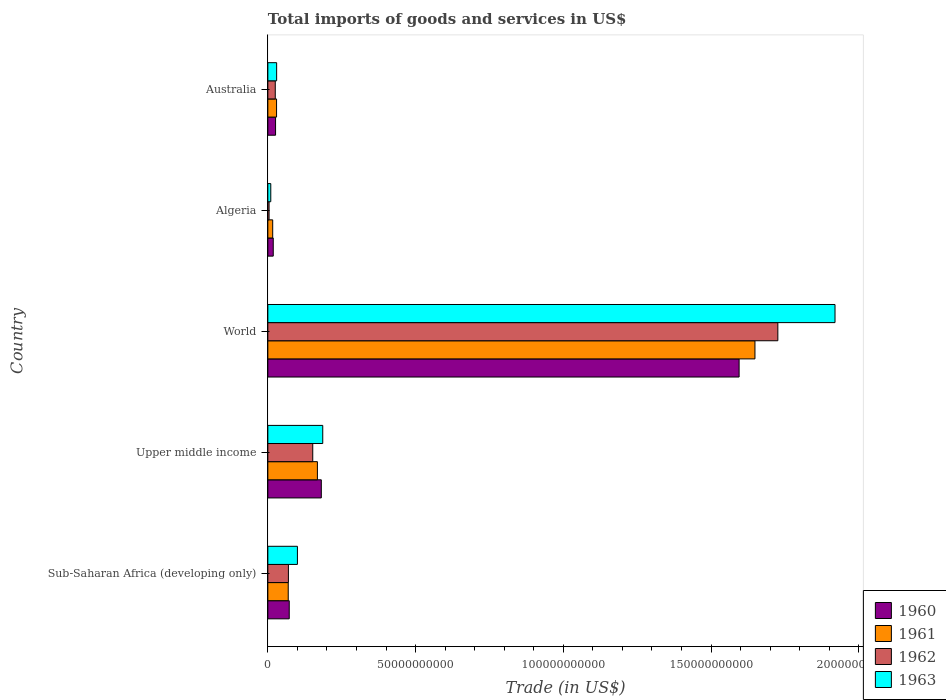How many bars are there on the 2nd tick from the top?
Your answer should be very brief. 4. What is the label of the 5th group of bars from the top?
Provide a short and direct response. Sub-Saharan Africa (developing only). In how many cases, is the number of bars for a given country not equal to the number of legend labels?
Ensure brevity in your answer.  0. What is the total imports of goods and services in 1962 in World?
Your answer should be compact. 1.73e+11. Across all countries, what is the maximum total imports of goods and services in 1963?
Give a very brief answer. 1.92e+11. Across all countries, what is the minimum total imports of goods and services in 1962?
Ensure brevity in your answer.  4.17e+08. In which country was the total imports of goods and services in 1962 maximum?
Offer a terse response. World. In which country was the total imports of goods and services in 1960 minimum?
Provide a succinct answer. Algeria. What is the total total imports of goods and services in 1961 in the graph?
Provide a succinct answer. 1.93e+11. What is the difference between the total imports of goods and services in 1962 in Upper middle income and that in World?
Your response must be concise. -1.57e+11. What is the difference between the total imports of goods and services in 1963 in Australia and the total imports of goods and services in 1962 in Upper middle income?
Your answer should be compact. -1.22e+1. What is the average total imports of goods and services in 1960 per country?
Provide a short and direct response. 3.79e+1. What is the difference between the total imports of goods and services in 1963 and total imports of goods and services in 1960 in Algeria?
Give a very brief answer. -8.33e+08. In how many countries, is the total imports of goods and services in 1963 greater than 100000000000 US$?
Make the answer very short. 1. What is the ratio of the total imports of goods and services in 1960 in Algeria to that in Sub-Saharan Africa (developing only)?
Offer a very short reply. 0.25. Is the difference between the total imports of goods and services in 1963 in Sub-Saharan Africa (developing only) and World greater than the difference between the total imports of goods and services in 1960 in Sub-Saharan Africa (developing only) and World?
Keep it short and to the point. No. What is the difference between the highest and the second highest total imports of goods and services in 1963?
Your response must be concise. 1.73e+11. What is the difference between the highest and the lowest total imports of goods and services in 1961?
Offer a terse response. 1.63e+11. Is it the case that in every country, the sum of the total imports of goods and services in 1961 and total imports of goods and services in 1963 is greater than the sum of total imports of goods and services in 1960 and total imports of goods and services in 1962?
Keep it short and to the point. No. What does the 4th bar from the top in World represents?
Ensure brevity in your answer.  1960. What does the 4th bar from the bottom in World represents?
Give a very brief answer. 1963. Is it the case that in every country, the sum of the total imports of goods and services in 1962 and total imports of goods and services in 1961 is greater than the total imports of goods and services in 1963?
Your answer should be compact. Yes. How many countries are there in the graph?
Your answer should be very brief. 5. Does the graph contain any zero values?
Ensure brevity in your answer.  No. Does the graph contain grids?
Make the answer very short. No. Where does the legend appear in the graph?
Provide a succinct answer. Bottom right. What is the title of the graph?
Make the answer very short. Total imports of goods and services in US$. Does "2000" appear as one of the legend labels in the graph?
Give a very brief answer. No. What is the label or title of the X-axis?
Your response must be concise. Trade (in US$). What is the Trade (in US$) of 1960 in Sub-Saharan Africa (developing only)?
Your answer should be very brief. 7.24e+09. What is the Trade (in US$) in 1961 in Sub-Saharan Africa (developing only)?
Ensure brevity in your answer.  6.90e+09. What is the Trade (in US$) in 1962 in Sub-Saharan Africa (developing only)?
Make the answer very short. 6.96e+09. What is the Trade (in US$) in 1963 in Sub-Saharan Africa (developing only)?
Your answer should be compact. 1.00e+1. What is the Trade (in US$) of 1960 in Upper middle income?
Your response must be concise. 1.81e+1. What is the Trade (in US$) of 1961 in Upper middle income?
Make the answer very short. 1.68e+1. What is the Trade (in US$) in 1962 in Upper middle income?
Offer a terse response. 1.52e+1. What is the Trade (in US$) in 1963 in Upper middle income?
Provide a short and direct response. 1.86e+1. What is the Trade (in US$) of 1960 in World?
Give a very brief answer. 1.59e+11. What is the Trade (in US$) in 1961 in World?
Keep it short and to the point. 1.65e+11. What is the Trade (in US$) of 1962 in World?
Provide a short and direct response. 1.73e+11. What is the Trade (in US$) of 1963 in World?
Your answer should be compact. 1.92e+11. What is the Trade (in US$) in 1960 in Algeria?
Provide a succinct answer. 1.83e+09. What is the Trade (in US$) of 1961 in Algeria?
Your answer should be compact. 1.64e+09. What is the Trade (in US$) in 1962 in Algeria?
Ensure brevity in your answer.  4.17e+08. What is the Trade (in US$) in 1963 in Algeria?
Provide a succinct answer. 9.95e+08. What is the Trade (in US$) of 1960 in Australia?
Give a very brief answer. 2.61e+09. What is the Trade (in US$) of 1961 in Australia?
Provide a short and direct response. 2.95e+09. What is the Trade (in US$) in 1962 in Australia?
Ensure brevity in your answer.  2.51e+09. What is the Trade (in US$) of 1963 in Australia?
Your answer should be very brief. 2.97e+09. Across all countries, what is the maximum Trade (in US$) of 1960?
Ensure brevity in your answer.  1.59e+11. Across all countries, what is the maximum Trade (in US$) of 1961?
Your answer should be compact. 1.65e+11. Across all countries, what is the maximum Trade (in US$) in 1962?
Provide a short and direct response. 1.73e+11. Across all countries, what is the maximum Trade (in US$) in 1963?
Offer a very short reply. 1.92e+11. Across all countries, what is the minimum Trade (in US$) in 1960?
Your response must be concise. 1.83e+09. Across all countries, what is the minimum Trade (in US$) in 1961?
Your answer should be compact. 1.64e+09. Across all countries, what is the minimum Trade (in US$) in 1962?
Keep it short and to the point. 4.17e+08. Across all countries, what is the minimum Trade (in US$) of 1963?
Your answer should be compact. 9.95e+08. What is the total Trade (in US$) in 1960 in the graph?
Offer a very short reply. 1.89e+11. What is the total Trade (in US$) in 1961 in the graph?
Offer a terse response. 1.93e+11. What is the total Trade (in US$) in 1962 in the graph?
Offer a very short reply. 1.98e+11. What is the total Trade (in US$) of 1963 in the graph?
Give a very brief answer. 2.25e+11. What is the difference between the Trade (in US$) in 1960 in Sub-Saharan Africa (developing only) and that in Upper middle income?
Ensure brevity in your answer.  -1.09e+1. What is the difference between the Trade (in US$) in 1961 in Sub-Saharan Africa (developing only) and that in Upper middle income?
Provide a short and direct response. -9.87e+09. What is the difference between the Trade (in US$) of 1962 in Sub-Saharan Africa (developing only) and that in Upper middle income?
Ensure brevity in your answer.  -8.24e+09. What is the difference between the Trade (in US$) in 1963 in Sub-Saharan Africa (developing only) and that in Upper middle income?
Provide a succinct answer. -8.57e+09. What is the difference between the Trade (in US$) in 1960 in Sub-Saharan Africa (developing only) and that in World?
Your answer should be compact. -1.52e+11. What is the difference between the Trade (in US$) in 1961 in Sub-Saharan Africa (developing only) and that in World?
Keep it short and to the point. -1.58e+11. What is the difference between the Trade (in US$) in 1962 in Sub-Saharan Africa (developing only) and that in World?
Ensure brevity in your answer.  -1.66e+11. What is the difference between the Trade (in US$) in 1963 in Sub-Saharan Africa (developing only) and that in World?
Provide a short and direct response. -1.82e+11. What is the difference between the Trade (in US$) of 1960 in Sub-Saharan Africa (developing only) and that in Algeria?
Provide a short and direct response. 5.41e+09. What is the difference between the Trade (in US$) of 1961 in Sub-Saharan Africa (developing only) and that in Algeria?
Ensure brevity in your answer.  5.26e+09. What is the difference between the Trade (in US$) of 1962 in Sub-Saharan Africa (developing only) and that in Algeria?
Your answer should be very brief. 6.54e+09. What is the difference between the Trade (in US$) of 1963 in Sub-Saharan Africa (developing only) and that in Algeria?
Provide a short and direct response. 9.02e+09. What is the difference between the Trade (in US$) in 1960 in Sub-Saharan Africa (developing only) and that in Australia?
Provide a short and direct response. 4.63e+09. What is the difference between the Trade (in US$) of 1961 in Sub-Saharan Africa (developing only) and that in Australia?
Your answer should be compact. 3.95e+09. What is the difference between the Trade (in US$) in 1962 in Sub-Saharan Africa (developing only) and that in Australia?
Your response must be concise. 4.45e+09. What is the difference between the Trade (in US$) in 1963 in Sub-Saharan Africa (developing only) and that in Australia?
Make the answer very short. 7.04e+09. What is the difference between the Trade (in US$) in 1960 in Upper middle income and that in World?
Offer a terse response. -1.41e+11. What is the difference between the Trade (in US$) in 1961 in Upper middle income and that in World?
Give a very brief answer. -1.48e+11. What is the difference between the Trade (in US$) in 1962 in Upper middle income and that in World?
Offer a terse response. -1.57e+11. What is the difference between the Trade (in US$) of 1963 in Upper middle income and that in World?
Your answer should be compact. -1.73e+11. What is the difference between the Trade (in US$) of 1960 in Upper middle income and that in Algeria?
Give a very brief answer. 1.63e+1. What is the difference between the Trade (in US$) in 1961 in Upper middle income and that in Algeria?
Offer a terse response. 1.51e+1. What is the difference between the Trade (in US$) of 1962 in Upper middle income and that in Algeria?
Ensure brevity in your answer.  1.48e+1. What is the difference between the Trade (in US$) in 1963 in Upper middle income and that in Algeria?
Keep it short and to the point. 1.76e+1. What is the difference between the Trade (in US$) of 1960 in Upper middle income and that in Australia?
Your answer should be compact. 1.55e+1. What is the difference between the Trade (in US$) in 1961 in Upper middle income and that in Australia?
Your response must be concise. 1.38e+1. What is the difference between the Trade (in US$) of 1962 in Upper middle income and that in Australia?
Provide a succinct answer. 1.27e+1. What is the difference between the Trade (in US$) of 1963 in Upper middle income and that in Australia?
Give a very brief answer. 1.56e+1. What is the difference between the Trade (in US$) of 1960 in World and that in Algeria?
Give a very brief answer. 1.58e+11. What is the difference between the Trade (in US$) of 1961 in World and that in Algeria?
Your response must be concise. 1.63e+11. What is the difference between the Trade (in US$) in 1962 in World and that in Algeria?
Provide a short and direct response. 1.72e+11. What is the difference between the Trade (in US$) in 1963 in World and that in Algeria?
Offer a very short reply. 1.91e+11. What is the difference between the Trade (in US$) in 1960 in World and that in Australia?
Give a very brief answer. 1.57e+11. What is the difference between the Trade (in US$) of 1961 in World and that in Australia?
Give a very brief answer. 1.62e+11. What is the difference between the Trade (in US$) in 1962 in World and that in Australia?
Your answer should be compact. 1.70e+11. What is the difference between the Trade (in US$) in 1963 in World and that in Australia?
Provide a succinct answer. 1.89e+11. What is the difference between the Trade (in US$) in 1960 in Algeria and that in Australia?
Provide a short and direct response. -7.83e+08. What is the difference between the Trade (in US$) of 1961 in Algeria and that in Australia?
Make the answer very short. -1.31e+09. What is the difference between the Trade (in US$) in 1962 in Algeria and that in Australia?
Provide a short and direct response. -2.10e+09. What is the difference between the Trade (in US$) of 1963 in Algeria and that in Australia?
Give a very brief answer. -1.98e+09. What is the difference between the Trade (in US$) in 1960 in Sub-Saharan Africa (developing only) and the Trade (in US$) in 1961 in Upper middle income?
Your answer should be compact. -9.54e+09. What is the difference between the Trade (in US$) in 1960 in Sub-Saharan Africa (developing only) and the Trade (in US$) in 1962 in Upper middle income?
Give a very brief answer. -7.96e+09. What is the difference between the Trade (in US$) in 1960 in Sub-Saharan Africa (developing only) and the Trade (in US$) in 1963 in Upper middle income?
Offer a terse response. -1.13e+1. What is the difference between the Trade (in US$) in 1961 in Sub-Saharan Africa (developing only) and the Trade (in US$) in 1962 in Upper middle income?
Your answer should be very brief. -8.29e+09. What is the difference between the Trade (in US$) of 1961 in Sub-Saharan Africa (developing only) and the Trade (in US$) of 1963 in Upper middle income?
Offer a very short reply. -1.17e+1. What is the difference between the Trade (in US$) in 1962 in Sub-Saharan Africa (developing only) and the Trade (in US$) in 1963 in Upper middle income?
Offer a very short reply. -1.16e+1. What is the difference between the Trade (in US$) in 1960 in Sub-Saharan Africa (developing only) and the Trade (in US$) in 1961 in World?
Provide a short and direct response. -1.58e+11. What is the difference between the Trade (in US$) in 1960 in Sub-Saharan Africa (developing only) and the Trade (in US$) in 1962 in World?
Provide a succinct answer. -1.65e+11. What is the difference between the Trade (in US$) of 1960 in Sub-Saharan Africa (developing only) and the Trade (in US$) of 1963 in World?
Give a very brief answer. -1.85e+11. What is the difference between the Trade (in US$) in 1961 in Sub-Saharan Africa (developing only) and the Trade (in US$) in 1962 in World?
Offer a terse response. -1.66e+11. What is the difference between the Trade (in US$) of 1961 in Sub-Saharan Africa (developing only) and the Trade (in US$) of 1963 in World?
Your answer should be compact. -1.85e+11. What is the difference between the Trade (in US$) in 1962 in Sub-Saharan Africa (developing only) and the Trade (in US$) in 1963 in World?
Offer a terse response. -1.85e+11. What is the difference between the Trade (in US$) of 1960 in Sub-Saharan Africa (developing only) and the Trade (in US$) of 1961 in Algeria?
Make the answer very short. 5.59e+09. What is the difference between the Trade (in US$) in 1960 in Sub-Saharan Africa (developing only) and the Trade (in US$) in 1962 in Algeria?
Ensure brevity in your answer.  6.82e+09. What is the difference between the Trade (in US$) of 1960 in Sub-Saharan Africa (developing only) and the Trade (in US$) of 1963 in Algeria?
Your answer should be very brief. 6.24e+09. What is the difference between the Trade (in US$) in 1961 in Sub-Saharan Africa (developing only) and the Trade (in US$) in 1962 in Algeria?
Offer a terse response. 6.49e+09. What is the difference between the Trade (in US$) of 1961 in Sub-Saharan Africa (developing only) and the Trade (in US$) of 1963 in Algeria?
Make the answer very short. 5.91e+09. What is the difference between the Trade (in US$) in 1962 in Sub-Saharan Africa (developing only) and the Trade (in US$) in 1963 in Algeria?
Your response must be concise. 5.97e+09. What is the difference between the Trade (in US$) of 1960 in Sub-Saharan Africa (developing only) and the Trade (in US$) of 1961 in Australia?
Give a very brief answer. 4.29e+09. What is the difference between the Trade (in US$) in 1960 in Sub-Saharan Africa (developing only) and the Trade (in US$) in 1962 in Australia?
Keep it short and to the point. 4.73e+09. What is the difference between the Trade (in US$) of 1960 in Sub-Saharan Africa (developing only) and the Trade (in US$) of 1963 in Australia?
Make the answer very short. 4.26e+09. What is the difference between the Trade (in US$) in 1961 in Sub-Saharan Africa (developing only) and the Trade (in US$) in 1962 in Australia?
Offer a very short reply. 4.39e+09. What is the difference between the Trade (in US$) in 1961 in Sub-Saharan Africa (developing only) and the Trade (in US$) in 1963 in Australia?
Keep it short and to the point. 3.93e+09. What is the difference between the Trade (in US$) in 1962 in Sub-Saharan Africa (developing only) and the Trade (in US$) in 1963 in Australia?
Provide a succinct answer. 3.99e+09. What is the difference between the Trade (in US$) in 1960 in Upper middle income and the Trade (in US$) in 1961 in World?
Keep it short and to the point. -1.47e+11. What is the difference between the Trade (in US$) of 1960 in Upper middle income and the Trade (in US$) of 1962 in World?
Ensure brevity in your answer.  -1.55e+11. What is the difference between the Trade (in US$) in 1960 in Upper middle income and the Trade (in US$) in 1963 in World?
Offer a terse response. -1.74e+11. What is the difference between the Trade (in US$) in 1961 in Upper middle income and the Trade (in US$) in 1962 in World?
Provide a succinct answer. -1.56e+11. What is the difference between the Trade (in US$) in 1961 in Upper middle income and the Trade (in US$) in 1963 in World?
Offer a very short reply. -1.75e+11. What is the difference between the Trade (in US$) of 1962 in Upper middle income and the Trade (in US$) of 1963 in World?
Your response must be concise. -1.77e+11. What is the difference between the Trade (in US$) of 1960 in Upper middle income and the Trade (in US$) of 1961 in Algeria?
Provide a succinct answer. 1.65e+1. What is the difference between the Trade (in US$) in 1960 in Upper middle income and the Trade (in US$) in 1962 in Algeria?
Your answer should be very brief. 1.77e+1. What is the difference between the Trade (in US$) of 1960 in Upper middle income and the Trade (in US$) of 1963 in Algeria?
Give a very brief answer. 1.71e+1. What is the difference between the Trade (in US$) in 1961 in Upper middle income and the Trade (in US$) in 1962 in Algeria?
Your response must be concise. 1.64e+1. What is the difference between the Trade (in US$) in 1961 in Upper middle income and the Trade (in US$) in 1963 in Algeria?
Make the answer very short. 1.58e+1. What is the difference between the Trade (in US$) in 1962 in Upper middle income and the Trade (in US$) in 1963 in Algeria?
Offer a terse response. 1.42e+1. What is the difference between the Trade (in US$) of 1960 in Upper middle income and the Trade (in US$) of 1961 in Australia?
Give a very brief answer. 1.51e+1. What is the difference between the Trade (in US$) in 1960 in Upper middle income and the Trade (in US$) in 1962 in Australia?
Provide a succinct answer. 1.56e+1. What is the difference between the Trade (in US$) of 1960 in Upper middle income and the Trade (in US$) of 1963 in Australia?
Your response must be concise. 1.51e+1. What is the difference between the Trade (in US$) in 1961 in Upper middle income and the Trade (in US$) in 1962 in Australia?
Offer a terse response. 1.43e+1. What is the difference between the Trade (in US$) in 1961 in Upper middle income and the Trade (in US$) in 1963 in Australia?
Keep it short and to the point. 1.38e+1. What is the difference between the Trade (in US$) in 1962 in Upper middle income and the Trade (in US$) in 1963 in Australia?
Make the answer very short. 1.22e+1. What is the difference between the Trade (in US$) in 1960 in World and the Trade (in US$) in 1961 in Algeria?
Your answer should be very brief. 1.58e+11. What is the difference between the Trade (in US$) in 1960 in World and the Trade (in US$) in 1962 in Algeria?
Keep it short and to the point. 1.59e+11. What is the difference between the Trade (in US$) of 1960 in World and the Trade (in US$) of 1963 in Algeria?
Give a very brief answer. 1.58e+11. What is the difference between the Trade (in US$) in 1961 in World and the Trade (in US$) in 1962 in Algeria?
Give a very brief answer. 1.64e+11. What is the difference between the Trade (in US$) of 1961 in World and the Trade (in US$) of 1963 in Algeria?
Offer a very short reply. 1.64e+11. What is the difference between the Trade (in US$) of 1962 in World and the Trade (in US$) of 1963 in Algeria?
Provide a short and direct response. 1.72e+11. What is the difference between the Trade (in US$) of 1960 in World and the Trade (in US$) of 1961 in Australia?
Offer a very short reply. 1.57e+11. What is the difference between the Trade (in US$) of 1960 in World and the Trade (in US$) of 1962 in Australia?
Your answer should be very brief. 1.57e+11. What is the difference between the Trade (in US$) in 1960 in World and the Trade (in US$) in 1963 in Australia?
Give a very brief answer. 1.57e+11. What is the difference between the Trade (in US$) in 1961 in World and the Trade (in US$) in 1962 in Australia?
Your answer should be compact. 1.62e+11. What is the difference between the Trade (in US$) of 1961 in World and the Trade (in US$) of 1963 in Australia?
Ensure brevity in your answer.  1.62e+11. What is the difference between the Trade (in US$) in 1962 in World and the Trade (in US$) in 1963 in Australia?
Give a very brief answer. 1.70e+11. What is the difference between the Trade (in US$) of 1960 in Algeria and the Trade (in US$) of 1961 in Australia?
Make the answer very short. -1.12e+09. What is the difference between the Trade (in US$) in 1960 in Algeria and the Trade (in US$) in 1962 in Australia?
Ensure brevity in your answer.  -6.83e+08. What is the difference between the Trade (in US$) in 1960 in Algeria and the Trade (in US$) in 1963 in Australia?
Give a very brief answer. -1.15e+09. What is the difference between the Trade (in US$) in 1961 in Algeria and the Trade (in US$) in 1962 in Australia?
Your answer should be very brief. -8.68e+08. What is the difference between the Trade (in US$) of 1961 in Algeria and the Trade (in US$) of 1963 in Australia?
Provide a short and direct response. -1.33e+09. What is the difference between the Trade (in US$) in 1962 in Algeria and the Trade (in US$) in 1963 in Australia?
Your answer should be very brief. -2.56e+09. What is the average Trade (in US$) in 1960 per country?
Provide a succinct answer. 3.79e+1. What is the average Trade (in US$) of 1961 per country?
Ensure brevity in your answer.  3.86e+1. What is the average Trade (in US$) in 1962 per country?
Ensure brevity in your answer.  3.95e+1. What is the average Trade (in US$) in 1963 per country?
Give a very brief answer. 4.49e+1. What is the difference between the Trade (in US$) of 1960 and Trade (in US$) of 1961 in Sub-Saharan Africa (developing only)?
Make the answer very short. 3.35e+08. What is the difference between the Trade (in US$) in 1960 and Trade (in US$) in 1962 in Sub-Saharan Africa (developing only)?
Provide a short and direct response. 2.77e+08. What is the difference between the Trade (in US$) in 1960 and Trade (in US$) in 1963 in Sub-Saharan Africa (developing only)?
Offer a very short reply. -2.77e+09. What is the difference between the Trade (in US$) in 1961 and Trade (in US$) in 1962 in Sub-Saharan Africa (developing only)?
Offer a very short reply. -5.79e+07. What is the difference between the Trade (in US$) of 1961 and Trade (in US$) of 1963 in Sub-Saharan Africa (developing only)?
Make the answer very short. -3.11e+09. What is the difference between the Trade (in US$) in 1962 and Trade (in US$) in 1963 in Sub-Saharan Africa (developing only)?
Provide a succinct answer. -3.05e+09. What is the difference between the Trade (in US$) in 1960 and Trade (in US$) in 1961 in Upper middle income?
Your answer should be very brief. 1.32e+09. What is the difference between the Trade (in US$) in 1960 and Trade (in US$) in 1962 in Upper middle income?
Your answer should be compact. 2.90e+09. What is the difference between the Trade (in US$) of 1960 and Trade (in US$) of 1963 in Upper middle income?
Provide a succinct answer. -4.87e+08. What is the difference between the Trade (in US$) of 1961 and Trade (in US$) of 1962 in Upper middle income?
Your response must be concise. 1.58e+09. What is the difference between the Trade (in US$) in 1961 and Trade (in US$) in 1963 in Upper middle income?
Your answer should be very brief. -1.81e+09. What is the difference between the Trade (in US$) of 1962 and Trade (in US$) of 1963 in Upper middle income?
Offer a very short reply. -3.39e+09. What is the difference between the Trade (in US$) of 1960 and Trade (in US$) of 1961 in World?
Your response must be concise. -5.36e+09. What is the difference between the Trade (in US$) of 1960 and Trade (in US$) of 1962 in World?
Offer a very short reply. -1.31e+1. What is the difference between the Trade (in US$) of 1960 and Trade (in US$) of 1963 in World?
Offer a very short reply. -3.25e+1. What is the difference between the Trade (in US$) of 1961 and Trade (in US$) of 1962 in World?
Provide a succinct answer. -7.75e+09. What is the difference between the Trade (in US$) in 1961 and Trade (in US$) in 1963 in World?
Make the answer very short. -2.71e+1. What is the difference between the Trade (in US$) of 1962 and Trade (in US$) of 1963 in World?
Provide a succinct answer. -1.93e+1. What is the difference between the Trade (in US$) in 1960 and Trade (in US$) in 1961 in Algeria?
Your response must be concise. 1.85e+08. What is the difference between the Trade (in US$) in 1960 and Trade (in US$) in 1962 in Algeria?
Your response must be concise. 1.41e+09. What is the difference between the Trade (in US$) in 1960 and Trade (in US$) in 1963 in Algeria?
Provide a short and direct response. 8.33e+08. What is the difference between the Trade (in US$) in 1961 and Trade (in US$) in 1962 in Algeria?
Offer a terse response. 1.23e+09. What is the difference between the Trade (in US$) in 1961 and Trade (in US$) in 1963 in Algeria?
Your answer should be compact. 6.48e+08. What is the difference between the Trade (in US$) in 1962 and Trade (in US$) in 1963 in Algeria?
Your answer should be very brief. -5.79e+08. What is the difference between the Trade (in US$) of 1960 and Trade (in US$) of 1961 in Australia?
Your answer should be very brief. -3.40e+08. What is the difference between the Trade (in US$) of 1960 and Trade (in US$) of 1962 in Australia?
Offer a terse response. 9.97e+07. What is the difference between the Trade (in US$) in 1960 and Trade (in US$) in 1963 in Australia?
Provide a short and direct response. -3.63e+08. What is the difference between the Trade (in US$) in 1961 and Trade (in US$) in 1962 in Australia?
Offer a very short reply. 4.40e+08. What is the difference between the Trade (in US$) in 1961 and Trade (in US$) in 1963 in Australia?
Offer a terse response. -2.24e+07. What is the difference between the Trade (in US$) of 1962 and Trade (in US$) of 1963 in Australia?
Give a very brief answer. -4.63e+08. What is the ratio of the Trade (in US$) in 1960 in Sub-Saharan Africa (developing only) to that in Upper middle income?
Ensure brevity in your answer.  0.4. What is the ratio of the Trade (in US$) of 1961 in Sub-Saharan Africa (developing only) to that in Upper middle income?
Provide a short and direct response. 0.41. What is the ratio of the Trade (in US$) of 1962 in Sub-Saharan Africa (developing only) to that in Upper middle income?
Offer a very short reply. 0.46. What is the ratio of the Trade (in US$) of 1963 in Sub-Saharan Africa (developing only) to that in Upper middle income?
Make the answer very short. 0.54. What is the ratio of the Trade (in US$) in 1960 in Sub-Saharan Africa (developing only) to that in World?
Give a very brief answer. 0.05. What is the ratio of the Trade (in US$) in 1961 in Sub-Saharan Africa (developing only) to that in World?
Your answer should be compact. 0.04. What is the ratio of the Trade (in US$) in 1962 in Sub-Saharan Africa (developing only) to that in World?
Your answer should be very brief. 0.04. What is the ratio of the Trade (in US$) of 1963 in Sub-Saharan Africa (developing only) to that in World?
Your answer should be compact. 0.05. What is the ratio of the Trade (in US$) of 1960 in Sub-Saharan Africa (developing only) to that in Algeria?
Give a very brief answer. 3.96. What is the ratio of the Trade (in US$) in 1961 in Sub-Saharan Africa (developing only) to that in Algeria?
Offer a very short reply. 4.2. What is the ratio of the Trade (in US$) in 1962 in Sub-Saharan Africa (developing only) to that in Algeria?
Give a very brief answer. 16.71. What is the ratio of the Trade (in US$) in 1963 in Sub-Saharan Africa (developing only) to that in Algeria?
Offer a terse response. 10.06. What is the ratio of the Trade (in US$) of 1960 in Sub-Saharan Africa (developing only) to that in Australia?
Ensure brevity in your answer.  2.77. What is the ratio of the Trade (in US$) of 1961 in Sub-Saharan Africa (developing only) to that in Australia?
Make the answer very short. 2.34. What is the ratio of the Trade (in US$) in 1962 in Sub-Saharan Africa (developing only) to that in Australia?
Offer a terse response. 2.77. What is the ratio of the Trade (in US$) of 1963 in Sub-Saharan Africa (developing only) to that in Australia?
Make the answer very short. 3.37. What is the ratio of the Trade (in US$) in 1960 in Upper middle income to that in World?
Your answer should be very brief. 0.11. What is the ratio of the Trade (in US$) of 1961 in Upper middle income to that in World?
Make the answer very short. 0.1. What is the ratio of the Trade (in US$) in 1962 in Upper middle income to that in World?
Your answer should be very brief. 0.09. What is the ratio of the Trade (in US$) in 1963 in Upper middle income to that in World?
Offer a very short reply. 0.1. What is the ratio of the Trade (in US$) in 1960 in Upper middle income to that in Algeria?
Offer a terse response. 9.89. What is the ratio of the Trade (in US$) of 1961 in Upper middle income to that in Algeria?
Ensure brevity in your answer.  10.21. What is the ratio of the Trade (in US$) in 1962 in Upper middle income to that in Algeria?
Keep it short and to the point. 36.47. What is the ratio of the Trade (in US$) in 1963 in Upper middle income to that in Algeria?
Make the answer very short. 18.67. What is the ratio of the Trade (in US$) of 1960 in Upper middle income to that in Australia?
Give a very brief answer. 6.93. What is the ratio of the Trade (in US$) of 1961 in Upper middle income to that in Australia?
Provide a succinct answer. 5.68. What is the ratio of the Trade (in US$) in 1962 in Upper middle income to that in Australia?
Your answer should be very brief. 6.05. What is the ratio of the Trade (in US$) of 1963 in Upper middle income to that in Australia?
Your answer should be compact. 6.25. What is the ratio of the Trade (in US$) of 1960 in World to that in Algeria?
Your answer should be compact. 87.21. What is the ratio of the Trade (in US$) of 1961 in World to that in Algeria?
Ensure brevity in your answer.  100.3. What is the ratio of the Trade (in US$) in 1962 in World to that in Algeria?
Offer a very short reply. 414.23. What is the ratio of the Trade (in US$) in 1963 in World to that in Algeria?
Your response must be concise. 192.84. What is the ratio of the Trade (in US$) of 1960 in World to that in Australia?
Your answer should be very brief. 61.07. What is the ratio of the Trade (in US$) of 1961 in World to that in Australia?
Ensure brevity in your answer.  55.84. What is the ratio of the Trade (in US$) in 1962 in World to that in Australia?
Give a very brief answer. 68.71. What is the ratio of the Trade (in US$) of 1963 in World to that in Australia?
Your response must be concise. 64.53. What is the ratio of the Trade (in US$) of 1960 in Algeria to that in Australia?
Give a very brief answer. 0.7. What is the ratio of the Trade (in US$) in 1961 in Algeria to that in Australia?
Provide a short and direct response. 0.56. What is the ratio of the Trade (in US$) of 1962 in Algeria to that in Australia?
Your answer should be compact. 0.17. What is the ratio of the Trade (in US$) of 1963 in Algeria to that in Australia?
Your response must be concise. 0.33. What is the difference between the highest and the second highest Trade (in US$) of 1960?
Ensure brevity in your answer.  1.41e+11. What is the difference between the highest and the second highest Trade (in US$) in 1961?
Provide a short and direct response. 1.48e+11. What is the difference between the highest and the second highest Trade (in US$) of 1962?
Give a very brief answer. 1.57e+11. What is the difference between the highest and the second highest Trade (in US$) of 1963?
Your answer should be very brief. 1.73e+11. What is the difference between the highest and the lowest Trade (in US$) of 1960?
Offer a very short reply. 1.58e+11. What is the difference between the highest and the lowest Trade (in US$) of 1961?
Ensure brevity in your answer.  1.63e+11. What is the difference between the highest and the lowest Trade (in US$) of 1962?
Your answer should be compact. 1.72e+11. What is the difference between the highest and the lowest Trade (in US$) of 1963?
Your answer should be compact. 1.91e+11. 